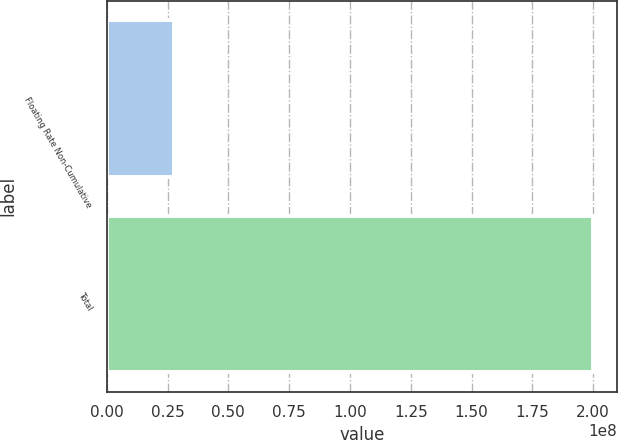Convert chart. <chart><loc_0><loc_0><loc_500><loc_500><bar_chart><fcel>Floating Rate Non-Cumulative<fcel>Total<nl><fcel>2.76e+07<fcel>2e+08<nl></chart> 